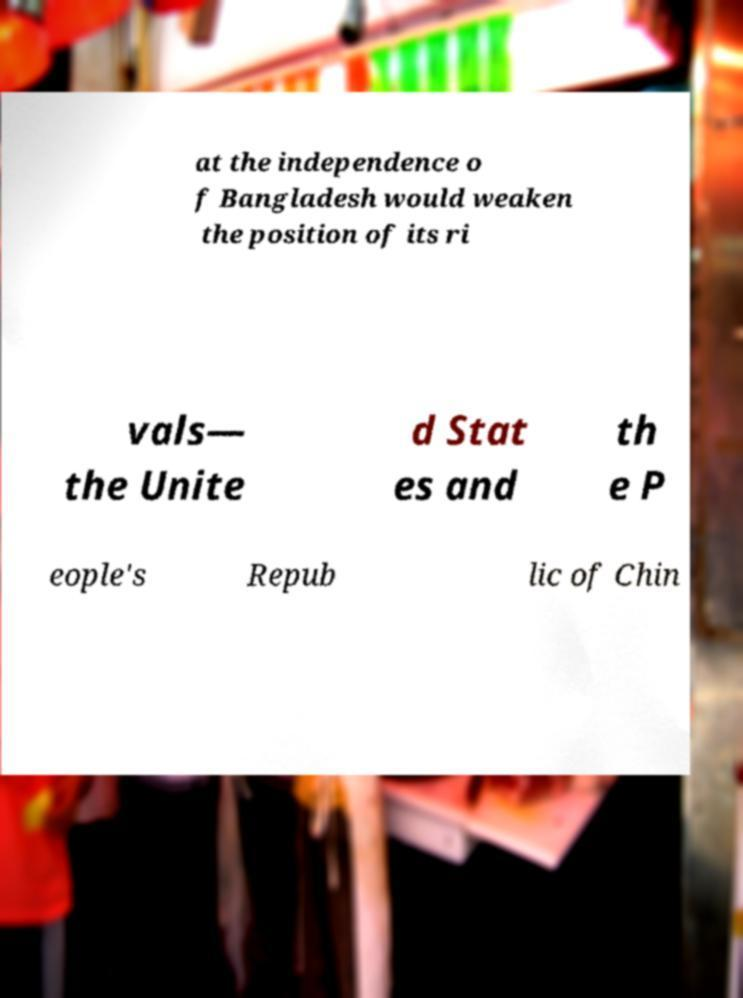Can you read and provide the text displayed in the image?This photo seems to have some interesting text. Can you extract and type it out for me? at the independence o f Bangladesh would weaken the position of its ri vals— the Unite d Stat es and th e P eople's Repub lic of Chin 